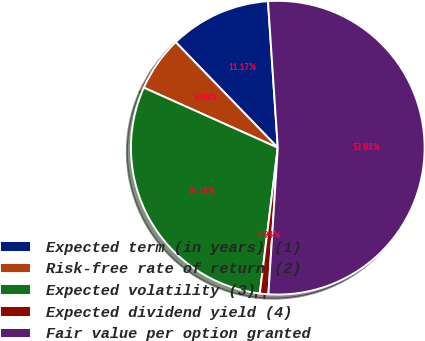Convert chart. <chart><loc_0><loc_0><loc_500><loc_500><pie_chart><fcel>Expected term (in years) (1)<fcel>Risk-free rate of return (2)<fcel>Expected volatility (3)<fcel>Expected dividend yield (4)<fcel>Fair value per option granted<nl><fcel>11.17%<fcel>6.06%<fcel>29.75%<fcel>0.94%<fcel>52.08%<nl></chart> 